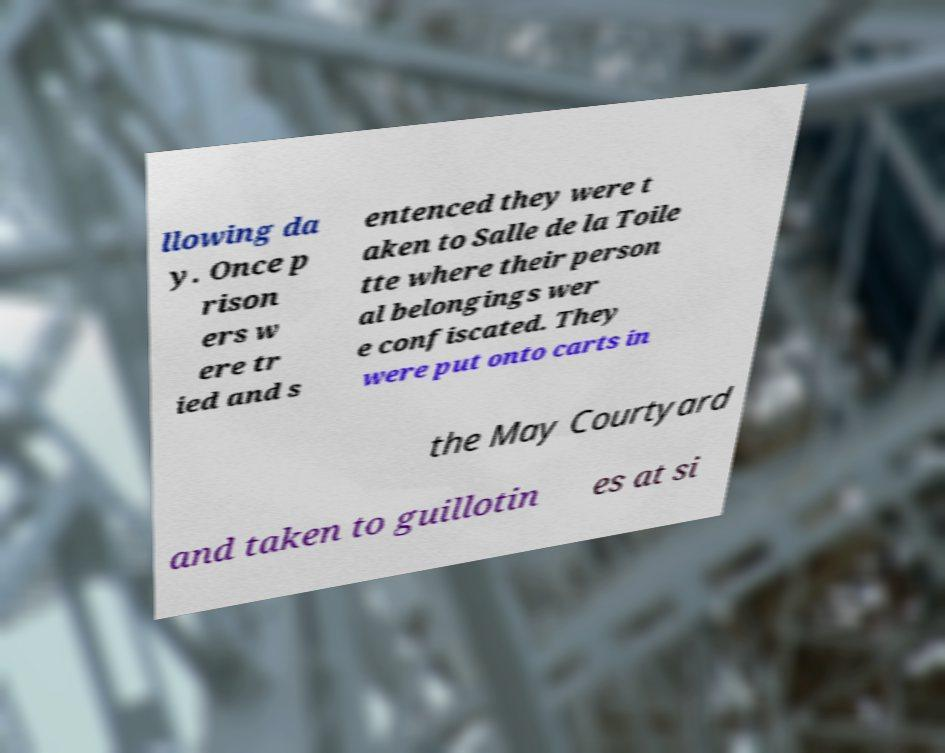Can you read and provide the text displayed in the image?This photo seems to have some interesting text. Can you extract and type it out for me? llowing da y. Once p rison ers w ere tr ied and s entenced they were t aken to Salle de la Toile tte where their person al belongings wer e confiscated. They were put onto carts in the May Courtyard and taken to guillotin es at si 